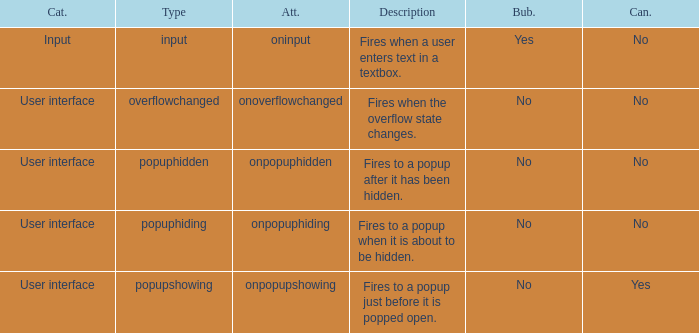What's the bubbles with attribute being onpopuphidden No. 